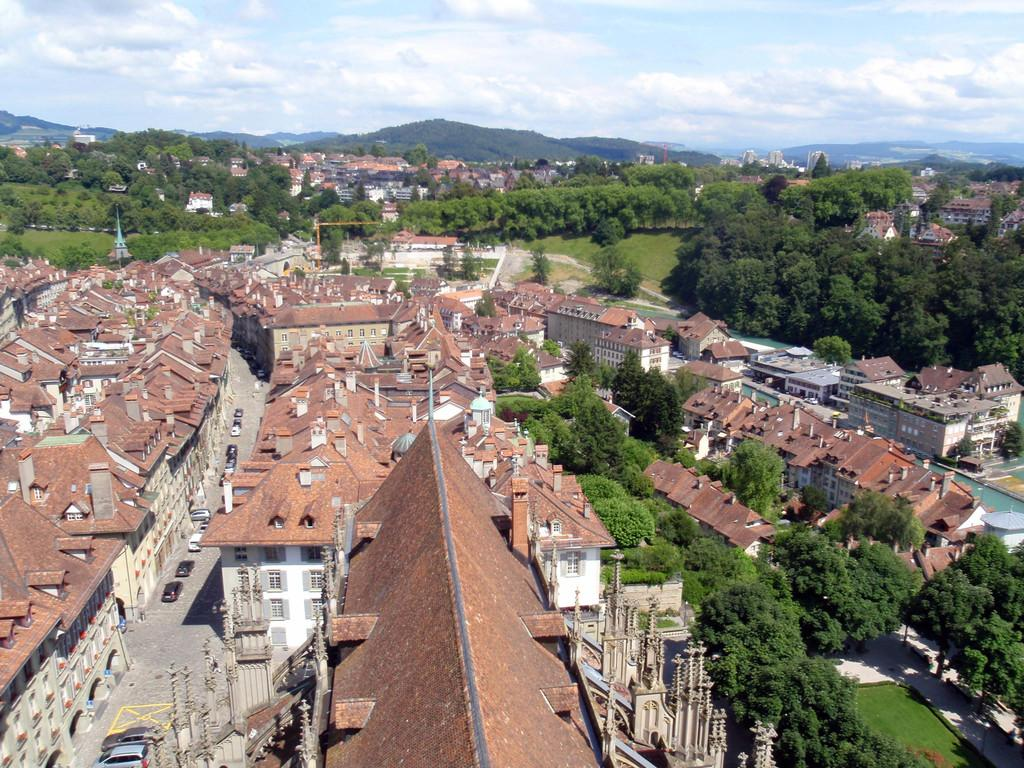What can be seen on the road in the image? There are vehicles on the road in the image. What structures are present in the image? There are buildings in the image. What type of vegetation is visible in the image? There are trees in the image. What geographical feature can be seen in the image? There are hills in the image. What is visible in the background of the image? The sky is visible in the background of the image. Can you tell me the title of the book the bear is reading in the image? There is no bear or book present in the image. How many girls are visible in the image? There are no girls present in the image. 